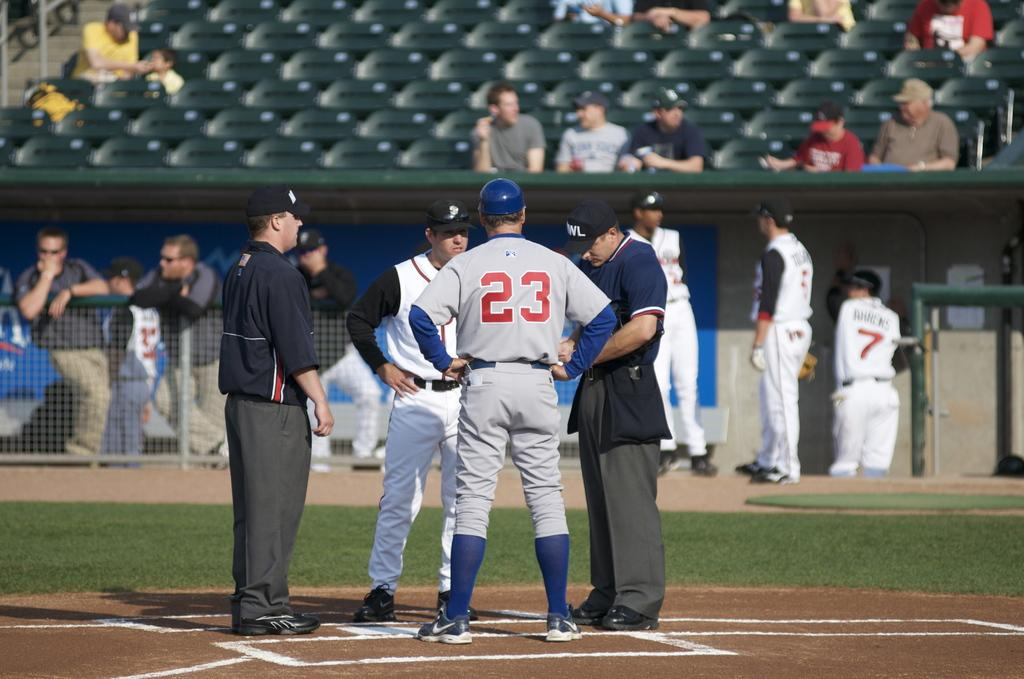<image>
Present a compact description of the photo's key features. A baseball player wearing the number 23 is in a huddle with three other people. 